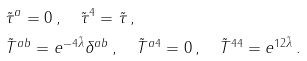<formula> <loc_0><loc_0><loc_500><loc_500>& \tilde { \tau } ^ { a } = 0 \, , \quad \tilde { \tau } ^ { 4 } = \tilde { \tau } \, , \\ & \tilde { T } ^ { a b } = e ^ { - 4 \tilde { \lambda } } \delta ^ { a b } \, , \quad \tilde { T } ^ { a 4 } = 0 \, , \quad \tilde { T } ^ { 4 4 } = e ^ { 1 2 \tilde { \lambda } } \, .</formula> 